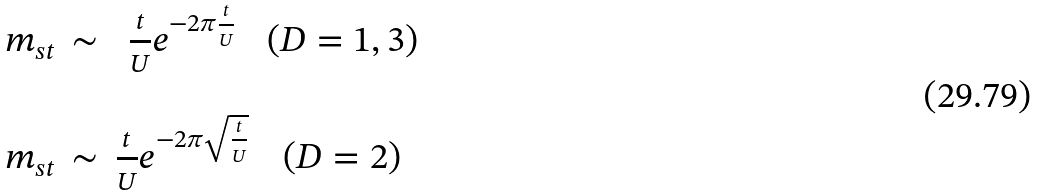Convert formula to latex. <formula><loc_0><loc_0><loc_500><loc_500>\begin{array} { c c c c } m _ { s t } & \sim & \frac { t } { U } e ^ { - 2 \pi \frac { t } { U } } & ( D = 1 , 3 ) \\ & & & \\ m _ { s t } & \sim & \frac { t } { U } e ^ { - 2 \pi \sqrt { \frac { t } { U } } } & ( D = 2 ) \end{array}</formula> 